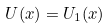<formula> <loc_0><loc_0><loc_500><loc_500>U ( x ) = U _ { 1 } ( x )</formula> 